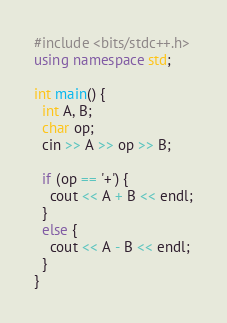Convert code to text. <code><loc_0><loc_0><loc_500><loc_500><_C++_>#include <bits/stdc++.h>
using namespace std;

int main() {
  int A, B;
  char op;
  cin >> A >> op >> B;
  
  if (op == '+') { 
    cout << A + B << endl;
  }
  else {
    cout << A - B << endl;
  }
}</code> 